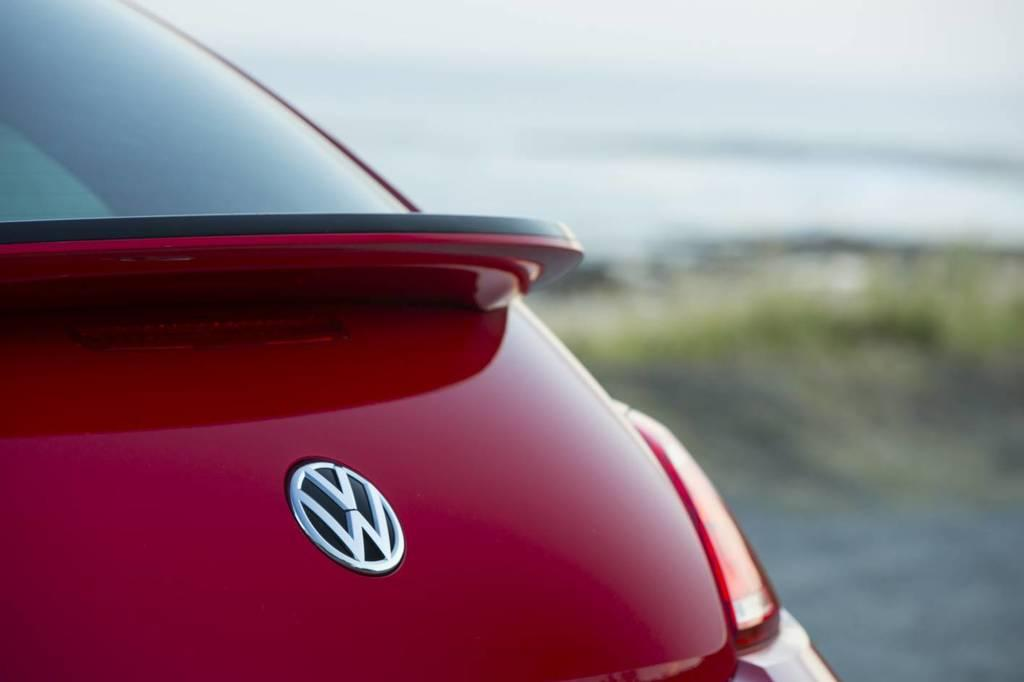What is the main subject of the image? There is a car in the image. Where is the car located in the image? The car is towards the left side of the image. What color is the car? The car is red in color. Can you see the car jumping over the ocean in the image? No, there is no car jumping over the ocean in the image. The image only features a red car located towards the left side. 